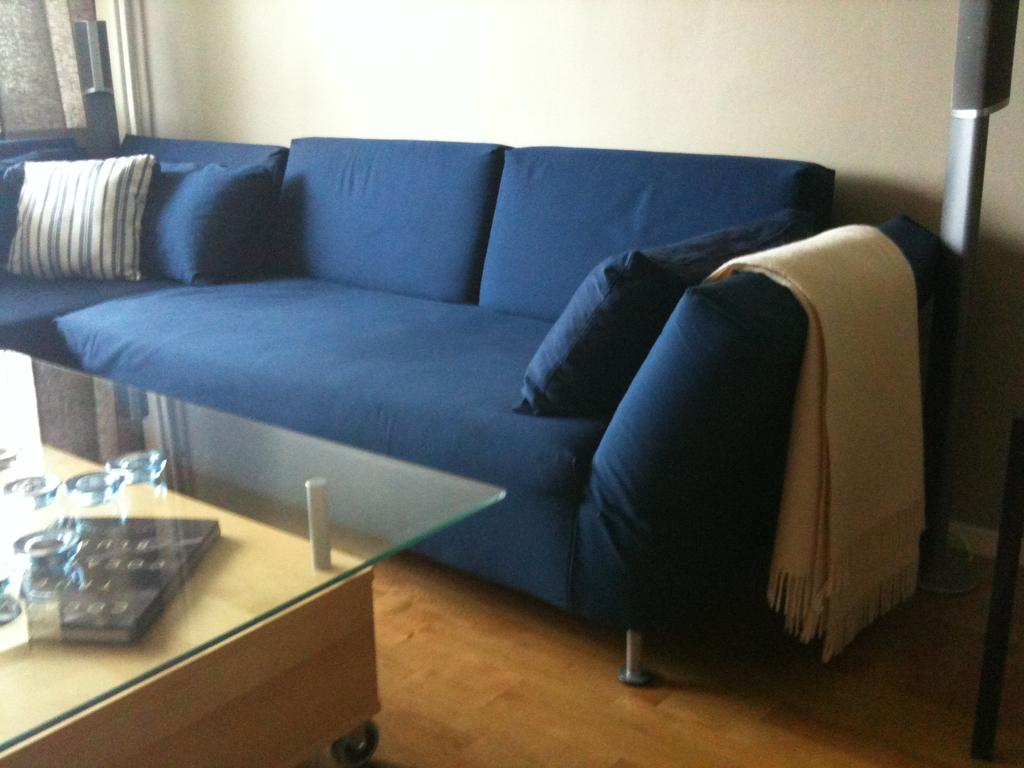What type of furniture is in the image? There is a sofa bed in the image. What is placed on the sofa bed? There are pillows on the sofa bed. What other soft item can be seen in the image? There is a cushion in the image. What is used for covering in the image? There is a blanket in the image. What piece of furniture is used for placing items on? There is a table in the image. How many children are playing with the knot in the image? There are no children or knots present in the image. What type of plants can be seen growing near the sofa bed? There are no plants visible in the image. 